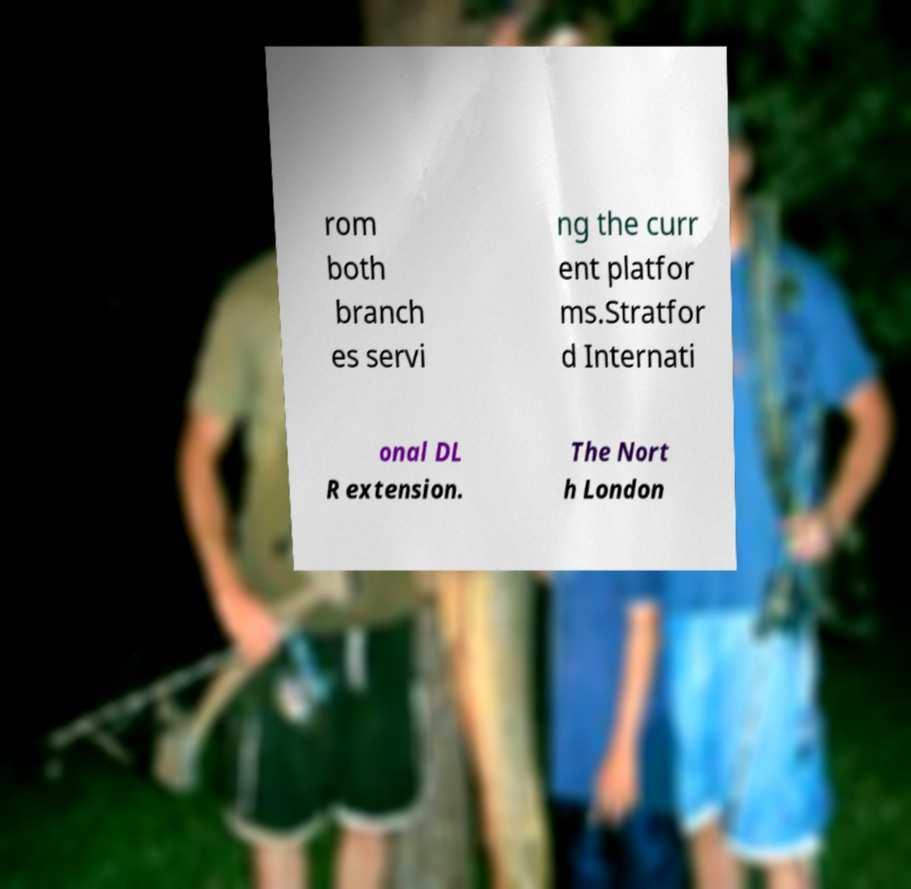Can you accurately transcribe the text from the provided image for me? rom both branch es servi ng the curr ent platfor ms.Stratfor d Internati onal DL R extension. The Nort h London 